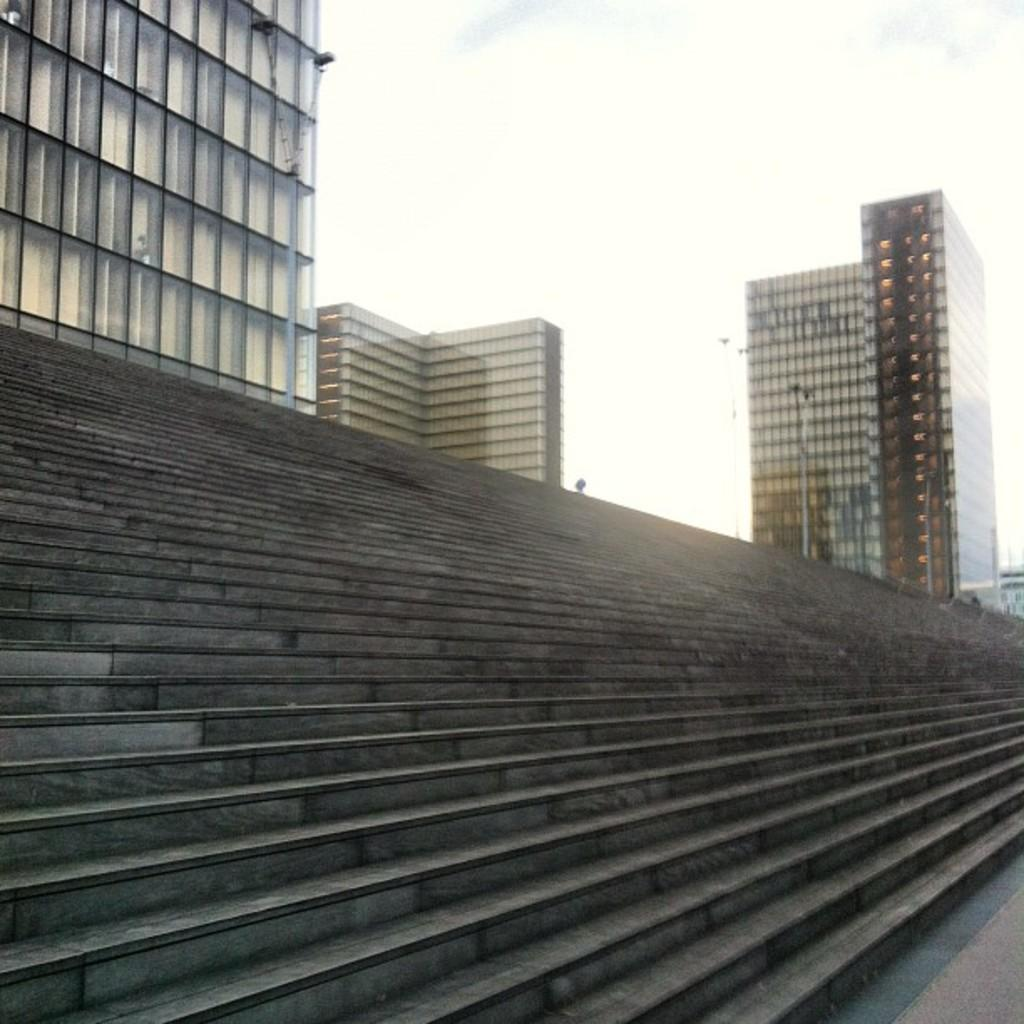What type of structure is present in the image? There are stairs in the image. What can be seen in the distance behind the stairs? There are buildings in the background of the image. What other objects are visible in the image? There are poles in the image. What is the condition of the sky in the image? The sky is clear in the image. Can you tell me how many dimes are scattered on the stairs in the image? There are no dimes present in the image; it only features stairs, buildings, and poles. What type of writing instrument is being used by the person talking on the stairs? There is no person talking or using a writing instrument in the image. 